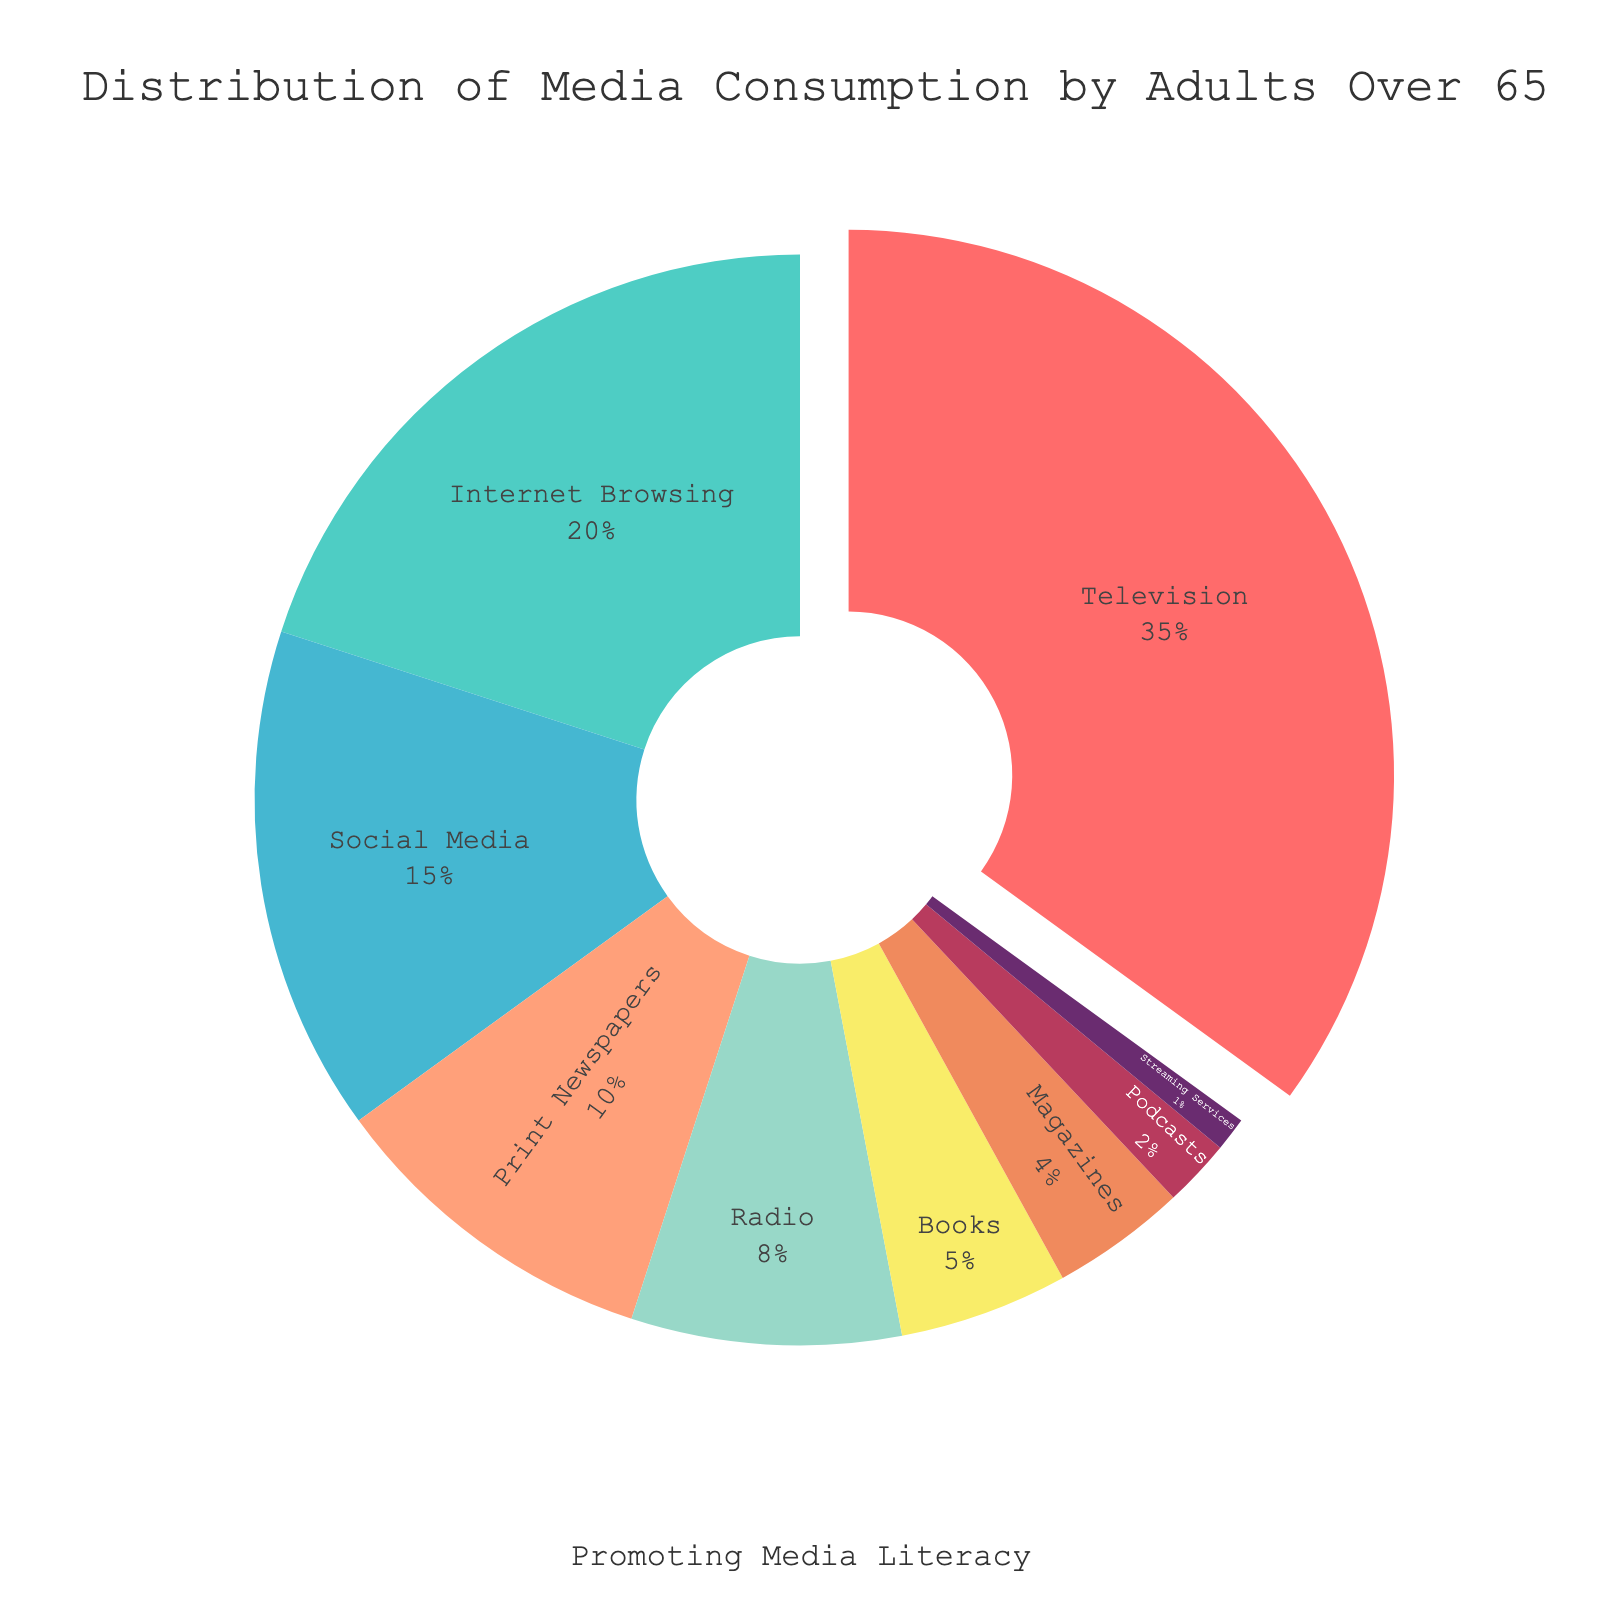what is the combined percentage of time spent on social media and Internet Browsing? Social Media accounts for 15% and Internet Browsing accounts for 20%. Adding them together gives 15% + 20% = 35%
Answer: 35% Which media type occupies the largest segment in the pie chart? Reviewing the chart, the media type with the largest segment is Television, which is 35%
Answer: Television What media type takes up the smallest share of the pie chart? The smallest segment in the pie chart is for Streaming Services, which is 1%
Answer: Streaming Services How much more time is spent on Television compared to Books? Time spent on Television is 35%, and on Books is 5%. The difference is 35% - 5% = 30%
Answer: 30% Compare the combined percentage of time spent on Radio and Podcasts versus Print Newspapers and Magazines. Which combination is greater? Radio and Podcasts together make up 8% + 2% = 10%. Print Newspapers and Magazines make up 10% + 4% = 14%. Here, Print Newspapers and Magazines have a higher combined percentage
Answer: Print Newspapers and Magazines Which media type is represented by the color red? In the custom color palette, the first color listed is red, and it corresponds to Television with 35% share
Answer: Television What proportion of the pie chart is taken up by media types that each account for less than 10%? Media types with less than 10% are Print Newspapers (10%), Radio (8%), Books (5%), Magazines (4%), Podcasts (2%), Streaming Services (1%). Adding these, 10% + 8% + 5% + 4% + 2% + 1% = 30%
Answer: 30% How much more time is spent on Social Media compared to Reading Books? Time spent on Social Media is 15%, whereas for Books it is 5%. The difference between them is 15% - 5% = 10%
Answer: 10% What is the second most consumed media type according to the pie chart? The second largest segment following Television is Internet Browsing, which accounts for 20%
Answer: Internet Browsing 